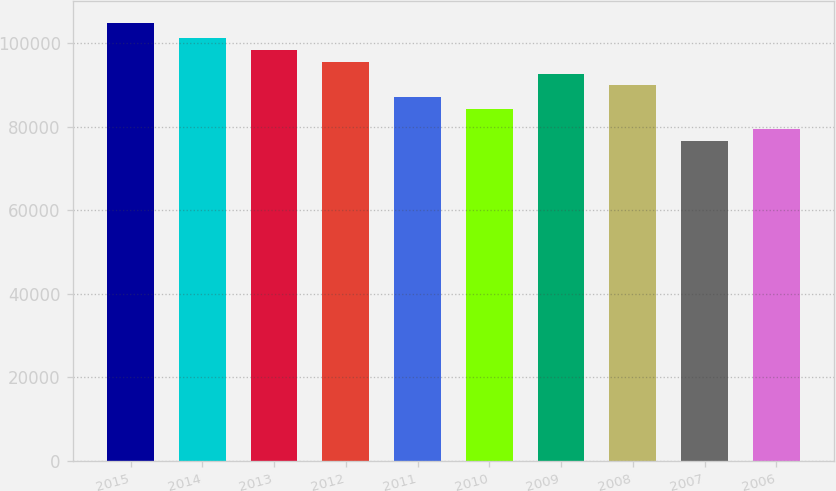Convert chart. <chart><loc_0><loc_0><loc_500><loc_500><bar_chart><fcel>2015<fcel>2014<fcel>2013<fcel>2012<fcel>2011<fcel>2010<fcel>2009<fcel>2008<fcel>2007<fcel>2006<nl><fcel>104862<fcel>101212<fcel>98377<fcel>95542.2<fcel>87037.8<fcel>84203<fcel>92707.4<fcel>89872.6<fcel>76514<fcel>79348.8<nl></chart> 